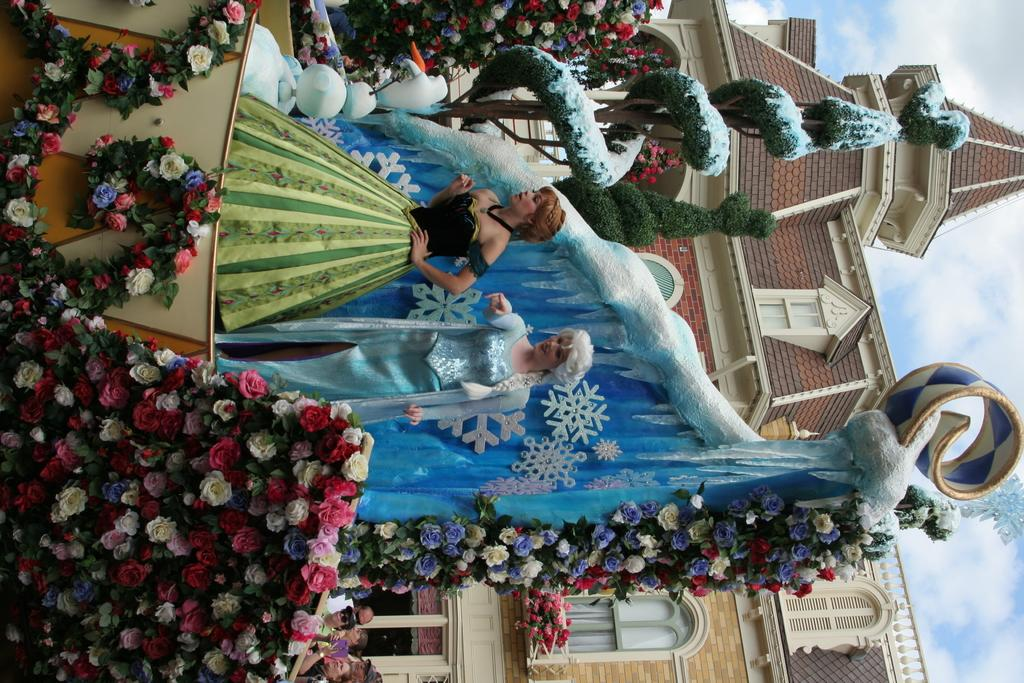How many mannequins are present in the image? There are two mannequins in the image. What is the appearance of the mannequins? The mannequins are decorated. What can be seen in the background of the image? There is a church in the background of the image. What type of owl can be seen perched on the church in the image? There is no owl present in the image; it only features two mannequins and a church in the background. 